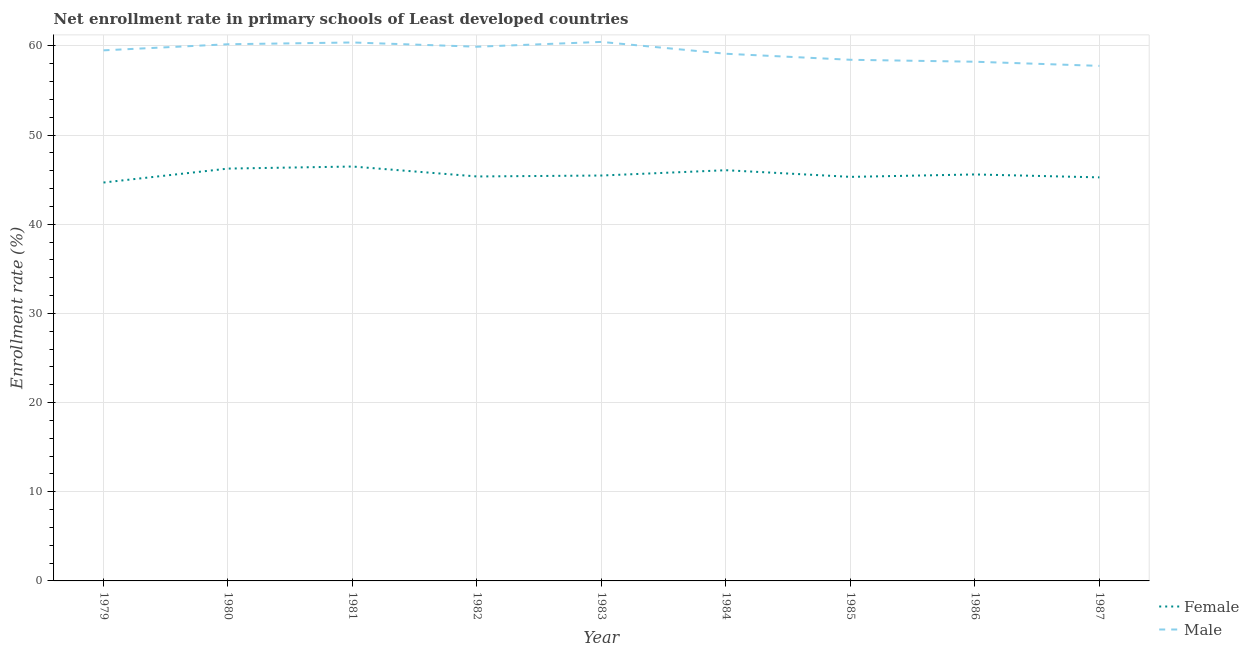How many different coloured lines are there?
Provide a succinct answer. 2. What is the enrollment rate of male students in 1982?
Provide a short and direct response. 59.9. Across all years, what is the maximum enrollment rate of female students?
Keep it short and to the point. 46.47. Across all years, what is the minimum enrollment rate of female students?
Provide a succinct answer. 44.68. In which year was the enrollment rate of male students maximum?
Provide a succinct answer. 1983. In which year was the enrollment rate of female students minimum?
Keep it short and to the point. 1979. What is the total enrollment rate of female students in the graph?
Keep it short and to the point. 410.4. What is the difference between the enrollment rate of male students in 1979 and that in 1982?
Make the answer very short. -0.41. What is the difference between the enrollment rate of male students in 1979 and the enrollment rate of female students in 1987?
Make the answer very short. 14.25. What is the average enrollment rate of female students per year?
Your answer should be compact. 45.6. In the year 1987, what is the difference between the enrollment rate of female students and enrollment rate of male students?
Offer a very short reply. -12.5. In how many years, is the enrollment rate of female students greater than 6 %?
Offer a terse response. 9. What is the ratio of the enrollment rate of female students in 1979 to that in 1982?
Your answer should be very brief. 0.99. Is the enrollment rate of female students in 1980 less than that in 1981?
Offer a terse response. Yes. Is the difference between the enrollment rate of female students in 1980 and 1984 greater than the difference between the enrollment rate of male students in 1980 and 1984?
Keep it short and to the point. No. What is the difference between the highest and the second highest enrollment rate of female students?
Offer a very short reply. 0.23. What is the difference between the highest and the lowest enrollment rate of female students?
Offer a very short reply. 1.79. In how many years, is the enrollment rate of male students greater than the average enrollment rate of male students taken over all years?
Your response must be concise. 5. Is the sum of the enrollment rate of female students in 1981 and 1984 greater than the maximum enrollment rate of male students across all years?
Your answer should be compact. Yes. Does the graph contain grids?
Keep it short and to the point. Yes. How many legend labels are there?
Ensure brevity in your answer.  2. How are the legend labels stacked?
Keep it short and to the point. Vertical. What is the title of the graph?
Keep it short and to the point. Net enrollment rate in primary schools of Least developed countries. What is the label or title of the Y-axis?
Provide a succinct answer. Enrollment rate (%). What is the Enrollment rate (%) in Female in 1979?
Keep it short and to the point. 44.68. What is the Enrollment rate (%) in Male in 1979?
Ensure brevity in your answer.  59.5. What is the Enrollment rate (%) in Female in 1980?
Provide a succinct answer. 46.24. What is the Enrollment rate (%) of Male in 1980?
Make the answer very short. 60.18. What is the Enrollment rate (%) of Female in 1981?
Make the answer very short. 46.47. What is the Enrollment rate (%) of Male in 1981?
Provide a short and direct response. 60.38. What is the Enrollment rate (%) in Female in 1982?
Your answer should be very brief. 45.36. What is the Enrollment rate (%) in Male in 1982?
Ensure brevity in your answer.  59.9. What is the Enrollment rate (%) in Female in 1983?
Your answer should be very brief. 45.46. What is the Enrollment rate (%) in Male in 1983?
Ensure brevity in your answer.  60.44. What is the Enrollment rate (%) of Female in 1984?
Make the answer very short. 46.06. What is the Enrollment rate (%) in Male in 1984?
Your answer should be compact. 59.12. What is the Enrollment rate (%) of Female in 1985?
Ensure brevity in your answer.  45.31. What is the Enrollment rate (%) in Male in 1985?
Keep it short and to the point. 58.44. What is the Enrollment rate (%) in Female in 1986?
Offer a very short reply. 45.58. What is the Enrollment rate (%) of Male in 1986?
Provide a short and direct response. 58.22. What is the Enrollment rate (%) in Female in 1987?
Keep it short and to the point. 45.25. What is the Enrollment rate (%) of Male in 1987?
Your answer should be very brief. 57.76. Across all years, what is the maximum Enrollment rate (%) of Female?
Keep it short and to the point. 46.47. Across all years, what is the maximum Enrollment rate (%) in Male?
Make the answer very short. 60.44. Across all years, what is the minimum Enrollment rate (%) of Female?
Make the answer very short. 44.68. Across all years, what is the minimum Enrollment rate (%) in Male?
Offer a terse response. 57.76. What is the total Enrollment rate (%) in Female in the graph?
Your answer should be very brief. 410.4. What is the total Enrollment rate (%) of Male in the graph?
Provide a succinct answer. 533.94. What is the difference between the Enrollment rate (%) of Female in 1979 and that in 1980?
Keep it short and to the point. -1.56. What is the difference between the Enrollment rate (%) in Male in 1979 and that in 1980?
Your answer should be very brief. -0.68. What is the difference between the Enrollment rate (%) in Female in 1979 and that in 1981?
Give a very brief answer. -1.79. What is the difference between the Enrollment rate (%) in Male in 1979 and that in 1981?
Ensure brevity in your answer.  -0.88. What is the difference between the Enrollment rate (%) in Female in 1979 and that in 1982?
Your answer should be compact. -0.68. What is the difference between the Enrollment rate (%) in Male in 1979 and that in 1982?
Provide a succinct answer. -0.41. What is the difference between the Enrollment rate (%) of Female in 1979 and that in 1983?
Offer a terse response. -0.78. What is the difference between the Enrollment rate (%) in Male in 1979 and that in 1983?
Offer a very short reply. -0.95. What is the difference between the Enrollment rate (%) of Female in 1979 and that in 1984?
Provide a succinct answer. -1.38. What is the difference between the Enrollment rate (%) of Male in 1979 and that in 1984?
Make the answer very short. 0.38. What is the difference between the Enrollment rate (%) of Female in 1979 and that in 1985?
Give a very brief answer. -0.63. What is the difference between the Enrollment rate (%) in Male in 1979 and that in 1985?
Your answer should be very brief. 1.06. What is the difference between the Enrollment rate (%) in Female in 1979 and that in 1986?
Ensure brevity in your answer.  -0.91. What is the difference between the Enrollment rate (%) of Male in 1979 and that in 1986?
Ensure brevity in your answer.  1.28. What is the difference between the Enrollment rate (%) of Female in 1979 and that in 1987?
Provide a succinct answer. -0.58. What is the difference between the Enrollment rate (%) of Male in 1979 and that in 1987?
Ensure brevity in your answer.  1.74. What is the difference between the Enrollment rate (%) of Female in 1980 and that in 1981?
Your response must be concise. -0.23. What is the difference between the Enrollment rate (%) in Male in 1980 and that in 1981?
Provide a succinct answer. -0.2. What is the difference between the Enrollment rate (%) in Female in 1980 and that in 1982?
Your response must be concise. 0.88. What is the difference between the Enrollment rate (%) of Male in 1980 and that in 1982?
Offer a very short reply. 0.28. What is the difference between the Enrollment rate (%) in Female in 1980 and that in 1983?
Offer a very short reply. 0.78. What is the difference between the Enrollment rate (%) of Male in 1980 and that in 1983?
Keep it short and to the point. -0.26. What is the difference between the Enrollment rate (%) of Female in 1980 and that in 1984?
Provide a succinct answer. 0.18. What is the difference between the Enrollment rate (%) in Male in 1980 and that in 1984?
Ensure brevity in your answer.  1.07. What is the difference between the Enrollment rate (%) of Male in 1980 and that in 1985?
Offer a very short reply. 1.74. What is the difference between the Enrollment rate (%) of Female in 1980 and that in 1986?
Offer a very short reply. 0.66. What is the difference between the Enrollment rate (%) in Male in 1980 and that in 1986?
Offer a very short reply. 1.96. What is the difference between the Enrollment rate (%) in Female in 1980 and that in 1987?
Ensure brevity in your answer.  0.99. What is the difference between the Enrollment rate (%) of Male in 1980 and that in 1987?
Your answer should be compact. 2.43. What is the difference between the Enrollment rate (%) in Female in 1981 and that in 1982?
Make the answer very short. 1.11. What is the difference between the Enrollment rate (%) in Male in 1981 and that in 1982?
Keep it short and to the point. 0.48. What is the difference between the Enrollment rate (%) of Female in 1981 and that in 1983?
Ensure brevity in your answer.  1.01. What is the difference between the Enrollment rate (%) of Male in 1981 and that in 1983?
Provide a short and direct response. -0.06. What is the difference between the Enrollment rate (%) in Female in 1981 and that in 1984?
Provide a short and direct response. 0.41. What is the difference between the Enrollment rate (%) in Male in 1981 and that in 1984?
Ensure brevity in your answer.  1.27. What is the difference between the Enrollment rate (%) in Female in 1981 and that in 1985?
Ensure brevity in your answer.  1.16. What is the difference between the Enrollment rate (%) of Male in 1981 and that in 1985?
Offer a terse response. 1.94. What is the difference between the Enrollment rate (%) of Female in 1981 and that in 1986?
Make the answer very short. 0.89. What is the difference between the Enrollment rate (%) of Male in 1981 and that in 1986?
Offer a terse response. 2.16. What is the difference between the Enrollment rate (%) of Female in 1981 and that in 1987?
Provide a succinct answer. 1.22. What is the difference between the Enrollment rate (%) in Male in 1981 and that in 1987?
Provide a succinct answer. 2.62. What is the difference between the Enrollment rate (%) of Female in 1982 and that in 1983?
Offer a very short reply. -0.1. What is the difference between the Enrollment rate (%) in Male in 1982 and that in 1983?
Your answer should be very brief. -0.54. What is the difference between the Enrollment rate (%) of Female in 1982 and that in 1984?
Provide a short and direct response. -0.7. What is the difference between the Enrollment rate (%) of Male in 1982 and that in 1984?
Provide a short and direct response. 0.79. What is the difference between the Enrollment rate (%) in Female in 1982 and that in 1985?
Keep it short and to the point. 0.05. What is the difference between the Enrollment rate (%) of Male in 1982 and that in 1985?
Your answer should be compact. 1.47. What is the difference between the Enrollment rate (%) of Female in 1982 and that in 1986?
Your answer should be compact. -0.23. What is the difference between the Enrollment rate (%) in Male in 1982 and that in 1986?
Offer a terse response. 1.68. What is the difference between the Enrollment rate (%) of Female in 1982 and that in 1987?
Your answer should be very brief. 0.1. What is the difference between the Enrollment rate (%) of Male in 1982 and that in 1987?
Your answer should be very brief. 2.15. What is the difference between the Enrollment rate (%) in Female in 1983 and that in 1984?
Your answer should be compact. -0.6. What is the difference between the Enrollment rate (%) of Male in 1983 and that in 1984?
Offer a terse response. 1.33. What is the difference between the Enrollment rate (%) of Female in 1983 and that in 1985?
Your answer should be compact. 0.15. What is the difference between the Enrollment rate (%) in Male in 1983 and that in 1985?
Your response must be concise. 2. What is the difference between the Enrollment rate (%) of Female in 1983 and that in 1986?
Offer a very short reply. -0.12. What is the difference between the Enrollment rate (%) in Male in 1983 and that in 1986?
Provide a short and direct response. 2.22. What is the difference between the Enrollment rate (%) in Female in 1983 and that in 1987?
Keep it short and to the point. 0.21. What is the difference between the Enrollment rate (%) in Male in 1983 and that in 1987?
Provide a succinct answer. 2.69. What is the difference between the Enrollment rate (%) in Female in 1984 and that in 1985?
Offer a terse response. 0.75. What is the difference between the Enrollment rate (%) in Male in 1984 and that in 1985?
Offer a terse response. 0.68. What is the difference between the Enrollment rate (%) of Female in 1984 and that in 1986?
Offer a terse response. 0.47. What is the difference between the Enrollment rate (%) in Male in 1984 and that in 1986?
Your response must be concise. 0.89. What is the difference between the Enrollment rate (%) of Female in 1984 and that in 1987?
Give a very brief answer. 0.8. What is the difference between the Enrollment rate (%) of Male in 1984 and that in 1987?
Your answer should be compact. 1.36. What is the difference between the Enrollment rate (%) of Female in 1985 and that in 1986?
Your answer should be very brief. -0.27. What is the difference between the Enrollment rate (%) in Male in 1985 and that in 1986?
Offer a terse response. 0.22. What is the difference between the Enrollment rate (%) in Female in 1985 and that in 1987?
Keep it short and to the point. 0.06. What is the difference between the Enrollment rate (%) in Male in 1985 and that in 1987?
Provide a short and direct response. 0.68. What is the difference between the Enrollment rate (%) of Female in 1986 and that in 1987?
Offer a very short reply. 0.33. What is the difference between the Enrollment rate (%) in Male in 1986 and that in 1987?
Offer a very short reply. 0.47. What is the difference between the Enrollment rate (%) in Female in 1979 and the Enrollment rate (%) in Male in 1980?
Provide a succinct answer. -15.51. What is the difference between the Enrollment rate (%) of Female in 1979 and the Enrollment rate (%) of Male in 1981?
Give a very brief answer. -15.7. What is the difference between the Enrollment rate (%) of Female in 1979 and the Enrollment rate (%) of Male in 1982?
Provide a succinct answer. -15.23. What is the difference between the Enrollment rate (%) in Female in 1979 and the Enrollment rate (%) in Male in 1983?
Your response must be concise. -15.77. What is the difference between the Enrollment rate (%) in Female in 1979 and the Enrollment rate (%) in Male in 1984?
Ensure brevity in your answer.  -14.44. What is the difference between the Enrollment rate (%) of Female in 1979 and the Enrollment rate (%) of Male in 1985?
Provide a short and direct response. -13.76. What is the difference between the Enrollment rate (%) in Female in 1979 and the Enrollment rate (%) in Male in 1986?
Your answer should be very brief. -13.54. What is the difference between the Enrollment rate (%) of Female in 1979 and the Enrollment rate (%) of Male in 1987?
Your answer should be compact. -13.08. What is the difference between the Enrollment rate (%) in Female in 1980 and the Enrollment rate (%) in Male in 1981?
Offer a very short reply. -14.14. What is the difference between the Enrollment rate (%) of Female in 1980 and the Enrollment rate (%) of Male in 1982?
Give a very brief answer. -13.67. What is the difference between the Enrollment rate (%) in Female in 1980 and the Enrollment rate (%) in Male in 1983?
Keep it short and to the point. -14.21. What is the difference between the Enrollment rate (%) of Female in 1980 and the Enrollment rate (%) of Male in 1984?
Make the answer very short. -12.88. What is the difference between the Enrollment rate (%) in Female in 1980 and the Enrollment rate (%) in Male in 1985?
Ensure brevity in your answer.  -12.2. What is the difference between the Enrollment rate (%) of Female in 1980 and the Enrollment rate (%) of Male in 1986?
Ensure brevity in your answer.  -11.98. What is the difference between the Enrollment rate (%) in Female in 1980 and the Enrollment rate (%) in Male in 1987?
Offer a very short reply. -11.52. What is the difference between the Enrollment rate (%) in Female in 1981 and the Enrollment rate (%) in Male in 1982?
Keep it short and to the point. -13.43. What is the difference between the Enrollment rate (%) of Female in 1981 and the Enrollment rate (%) of Male in 1983?
Offer a terse response. -13.97. What is the difference between the Enrollment rate (%) of Female in 1981 and the Enrollment rate (%) of Male in 1984?
Your answer should be compact. -12.64. What is the difference between the Enrollment rate (%) in Female in 1981 and the Enrollment rate (%) in Male in 1985?
Offer a very short reply. -11.97. What is the difference between the Enrollment rate (%) of Female in 1981 and the Enrollment rate (%) of Male in 1986?
Make the answer very short. -11.75. What is the difference between the Enrollment rate (%) of Female in 1981 and the Enrollment rate (%) of Male in 1987?
Make the answer very short. -11.29. What is the difference between the Enrollment rate (%) in Female in 1982 and the Enrollment rate (%) in Male in 1983?
Offer a very short reply. -15.09. What is the difference between the Enrollment rate (%) of Female in 1982 and the Enrollment rate (%) of Male in 1984?
Keep it short and to the point. -13.76. What is the difference between the Enrollment rate (%) of Female in 1982 and the Enrollment rate (%) of Male in 1985?
Provide a succinct answer. -13.08. What is the difference between the Enrollment rate (%) of Female in 1982 and the Enrollment rate (%) of Male in 1986?
Offer a terse response. -12.87. What is the difference between the Enrollment rate (%) of Female in 1982 and the Enrollment rate (%) of Male in 1987?
Make the answer very short. -12.4. What is the difference between the Enrollment rate (%) of Female in 1983 and the Enrollment rate (%) of Male in 1984?
Your answer should be very brief. -13.65. What is the difference between the Enrollment rate (%) in Female in 1983 and the Enrollment rate (%) in Male in 1985?
Offer a very short reply. -12.98. What is the difference between the Enrollment rate (%) of Female in 1983 and the Enrollment rate (%) of Male in 1986?
Keep it short and to the point. -12.76. What is the difference between the Enrollment rate (%) in Female in 1983 and the Enrollment rate (%) in Male in 1987?
Ensure brevity in your answer.  -12.3. What is the difference between the Enrollment rate (%) of Female in 1984 and the Enrollment rate (%) of Male in 1985?
Your response must be concise. -12.38. What is the difference between the Enrollment rate (%) in Female in 1984 and the Enrollment rate (%) in Male in 1986?
Your answer should be very brief. -12.16. What is the difference between the Enrollment rate (%) in Female in 1984 and the Enrollment rate (%) in Male in 1987?
Keep it short and to the point. -11.7. What is the difference between the Enrollment rate (%) of Female in 1985 and the Enrollment rate (%) of Male in 1986?
Offer a terse response. -12.91. What is the difference between the Enrollment rate (%) of Female in 1985 and the Enrollment rate (%) of Male in 1987?
Offer a terse response. -12.45. What is the difference between the Enrollment rate (%) of Female in 1986 and the Enrollment rate (%) of Male in 1987?
Ensure brevity in your answer.  -12.17. What is the average Enrollment rate (%) in Female per year?
Your response must be concise. 45.6. What is the average Enrollment rate (%) in Male per year?
Your answer should be very brief. 59.33. In the year 1979, what is the difference between the Enrollment rate (%) in Female and Enrollment rate (%) in Male?
Your answer should be compact. -14.82. In the year 1980, what is the difference between the Enrollment rate (%) of Female and Enrollment rate (%) of Male?
Give a very brief answer. -13.94. In the year 1981, what is the difference between the Enrollment rate (%) in Female and Enrollment rate (%) in Male?
Make the answer very short. -13.91. In the year 1982, what is the difference between the Enrollment rate (%) of Female and Enrollment rate (%) of Male?
Make the answer very short. -14.55. In the year 1983, what is the difference between the Enrollment rate (%) in Female and Enrollment rate (%) in Male?
Your answer should be very brief. -14.98. In the year 1984, what is the difference between the Enrollment rate (%) of Female and Enrollment rate (%) of Male?
Provide a short and direct response. -13.06. In the year 1985, what is the difference between the Enrollment rate (%) in Female and Enrollment rate (%) in Male?
Keep it short and to the point. -13.13. In the year 1986, what is the difference between the Enrollment rate (%) in Female and Enrollment rate (%) in Male?
Ensure brevity in your answer.  -12.64. In the year 1987, what is the difference between the Enrollment rate (%) in Female and Enrollment rate (%) in Male?
Provide a short and direct response. -12.5. What is the ratio of the Enrollment rate (%) in Female in 1979 to that in 1980?
Offer a very short reply. 0.97. What is the ratio of the Enrollment rate (%) of Male in 1979 to that in 1980?
Offer a terse response. 0.99. What is the ratio of the Enrollment rate (%) in Female in 1979 to that in 1981?
Your answer should be very brief. 0.96. What is the ratio of the Enrollment rate (%) in Male in 1979 to that in 1981?
Your answer should be very brief. 0.99. What is the ratio of the Enrollment rate (%) of Female in 1979 to that in 1982?
Provide a succinct answer. 0.98. What is the ratio of the Enrollment rate (%) of Female in 1979 to that in 1983?
Offer a terse response. 0.98. What is the ratio of the Enrollment rate (%) in Male in 1979 to that in 1983?
Ensure brevity in your answer.  0.98. What is the ratio of the Enrollment rate (%) of Female in 1979 to that in 1984?
Offer a terse response. 0.97. What is the ratio of the Enrollment rate (%) in Female in 1979 to that in 1985?
Ensure brevity in your answer.  0.99. What is the ratio of the Enrollment rate (%) in Male in 1979 to that in 1985?
Provide a succinct answer. 1.02. What is the ratio of the Enrollment rate (%) of Female in 1979 to that in 1986?
Offer a very short reply. 0.98. What is the ratio of the Enrollment rate (%) in Male in 1979 to that in 1986?
Ensure brevity in your answer.  1.02. What is the ratio of the Enrollment rate (%) in Female in 1979 to that in 1987?
Offer a terse response. 0.99. What is the ratio of the Enrollment rate (%) of Male in 1979 to that in 1987?
Keep it short and to the point. 1.03. What is the ratio of the Enrollment rate (%) in Female in 1980 to that in 1981?
Your answer should be very brief. 0.99. What is the ratio of the Enrollment rate (%) in Male in 1980 to that in 1981?
Your answer should be very brief. 1. What is the ratio of the Enrollment rate (%) of Female in 1980 to that in 1982?
Your answer should be compact. 1.02. What is the ratio of the Enrollment rate (%) of Male in 1980 to that in 1982?
Make the answer very short. 1. What is the ratio of the Enrollment rate (%) in Female in 1980 to that in 1983?
Offer a very short reply. 1.02. What is the ratio of the Enrollment rate (%) of Female in 1980 to that in 1984?
Ensure brevity in your answer.  1. What is the ratio of the Enrollment rate (%) in Female in 1980 to that in 1985?
Provide a short and direct response. 1.02. What is the ratio of the Enrollment rate (%) in Male in 1980 to that in 1985?
Provide a succinct answer. 1.03. What is the ratio of the Enrollment rate (%) in Female in 1980 to that in 1986?
Ensure brevity in your answer.  1.01. What is the ratio of the Enrollment rate (%) of Male in 1980 to that in 1986?
Make the answer very short. 1.03. What is the ratio of the Enrollment rate (%) in Female in 1980 to that in 1987?
Keep it short and to the point. 1.02. What is the ratio of the Enrollment rate (%) of Male in 1980 to that in 1987?
Offer a very short reply. 1.04. What is the ratio of the Enrollment rate (%) of Female in 1981 to that in 1982?
Provide a short and direct response. 1.02. What is the ratio of the Enrollment rate (%) of Male in 1981 to that in 1982?
Make the answer very short. 1.01. What is the ratio of the Enrollment rate (%) in Female in 1981 to that in 1983?
Provide a succinct answer. 1.02. What is the ratio of the Enrollment rate (%) of Male in 1981 to that in 1983?
Keep it short and to the point. 1. What is the ratio of the Enrollment rate (%) in Female in 1981 to that in 1984?
Keep it short and to the point. 1.01. What is the ratio of the Enrollment rate (%) of Male in 1981 to that in 1984?
Your response must be concise. 1.02. What is the ratio of the Enrollment rate (%) in Female in 1981 to that in 1985?
Your response must be concise. 1.03. What is the ratio of the Enrollment rate (%) of Male in 1981 to that in 1985?
Make the answer very short. 1.03. What is the ratio of the Enrollment rate (%) of Female in 1981 to that in 1986?
Give a very brief answer. 1.02. What is the ratio of the Enrollment rate (%) in Male in 1981 to that in 1986?
Offer a terse response. 1.04. What is the ratio of the Enrollment rate (%) in Female in 1981 to that in 1987?
Keep it short and to the point. 1.03. What is the ratio of the Enrollment rate (%) of Male in 1981 to that in 1987?
Offer a very short reply. 1.05. What is the ratio of the Enrollment rate (%) in Female in 1982 to that in 1983?
Offer a terse response. 1. What is the ratio of the Enrollment rate (%) in Male in 1982 to that in 1984?
Keep it short and to the point. 1.01. What is the ratio of the Enrollment rate (%) in Male in 1982 to that in 1985?
Offer a very short reply. 1.03. What is the ratio of the Enrollment rate (%) of Female in 1982 to that in 1986?
Provide a short and direct response. 0.99. What is the ratio of the Enrollment rate (%) in Male in 1982 to that in 1986?
Offer a terse response. 1.03. What is the ratio of the Enrollment rate (%) in Male in 1982 to that in 1987?
Offer a terse response. 1.04. What is the ratio of the Enrollment rate (%) of Female in 1983 to that in 1984?
Keep it short and to the point. 0.99. What is the ratio of the Enrollment rate (%) of Male in 1983 to that in 1984?
Keep it short and to the point. 1.02. What is the ratio of the Enrollment rate (%) of Female in 1983 to that in 1985?
Offer a very short reply. 1. What is the ratio of the Enrollment rate (%) of Male in 1983 to that in 1985?
Provide a succinct answer. 1.03. What is the ratio of the Enrollment rate (%) in Male in 1983 to that in 1986?
Give a very brief answer. 1.04. What is the ratio of the Enrollment rate (%) in Male in 1983 to that in 1987?
Your response must be concise. 1.05. What is the ratio of the Enrollment rate (%) of Female in 1984 to that in 1985?
Your response must be concise. 1.02. What is the ratio of the Enrollment rate (%) of Male in 1984 to that in 1985?
Offer a very short reply. 1.01. What is the ratio of the Enrollment rate (%) in Female in 1984 to that in 1986?
Keep it short and to the point. 1.01. What is the ratio of the Enrollment rate (%) of Male in 1984 to that in 1986?
Provide a short and direct response. 1.02. What is the ratio of the Enrollment rate (%) of Female in 1984 to that in 1987?
Keep it short and to the point. 1.02. What is the ratio of the Enrollment rate (%) of Male in 1984 to that in 1987?
Give a very brief answer. 1.02. What is the ratio of the Enrollment rate (%) of Male in 1985 to that in 1986?
Your answer should be very brief. 1. What is the ratio of the Enrollment rate (%) in Male in 1985 to that in 1987?
Ensure brevity in your answer.  1.01. What is the ratio of the Enrollment rate (%) of Female in 1986 to that in 1987?
Offer a terse response. 1.01. What is the ratio of the Enrollment rate (%) in Male in 1986 to that in 1987?
Your response must be concise. 1.01. What is the difference between the highest and the second highest Enrollment rate (%) in Female?
Your answer should be compact. 0.23. What is the difference between the highest and the second highest Enrollment rate (%) in Male?
Provide a short and direct response. 0.06. What is the difference between the highest and the lowest Enrollment rate (%) of Female?
Provide a succinct answer. 1.79. What is the difference between the highest and the lowest Enrollment rate (%) of Male?
Offer a very short reply. 2.69. 